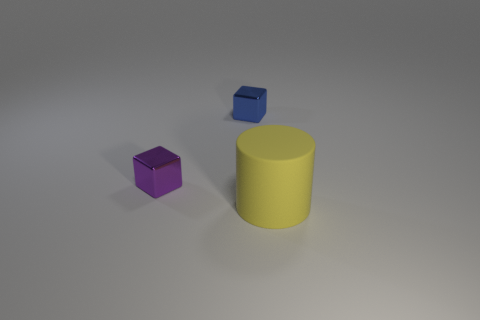Add 1 cyan matte cylinders. How many objects exist? 4 Subtract all cylinders. How many objects are left? 2 Add 3 tiny blue objects. How many tiny blue objects exist? 4 Subtract 0 red spheres. How many objects are left? 3 Subtract all gray cylinders. Subtract all green cubes. How many cylinders are left? 1 Subtract all yellow rubber things. Subtract all blue shiny cubes. How many objects are left? 1 Add 3 purple shiny objects. How many purple shiny objects are left? 4 